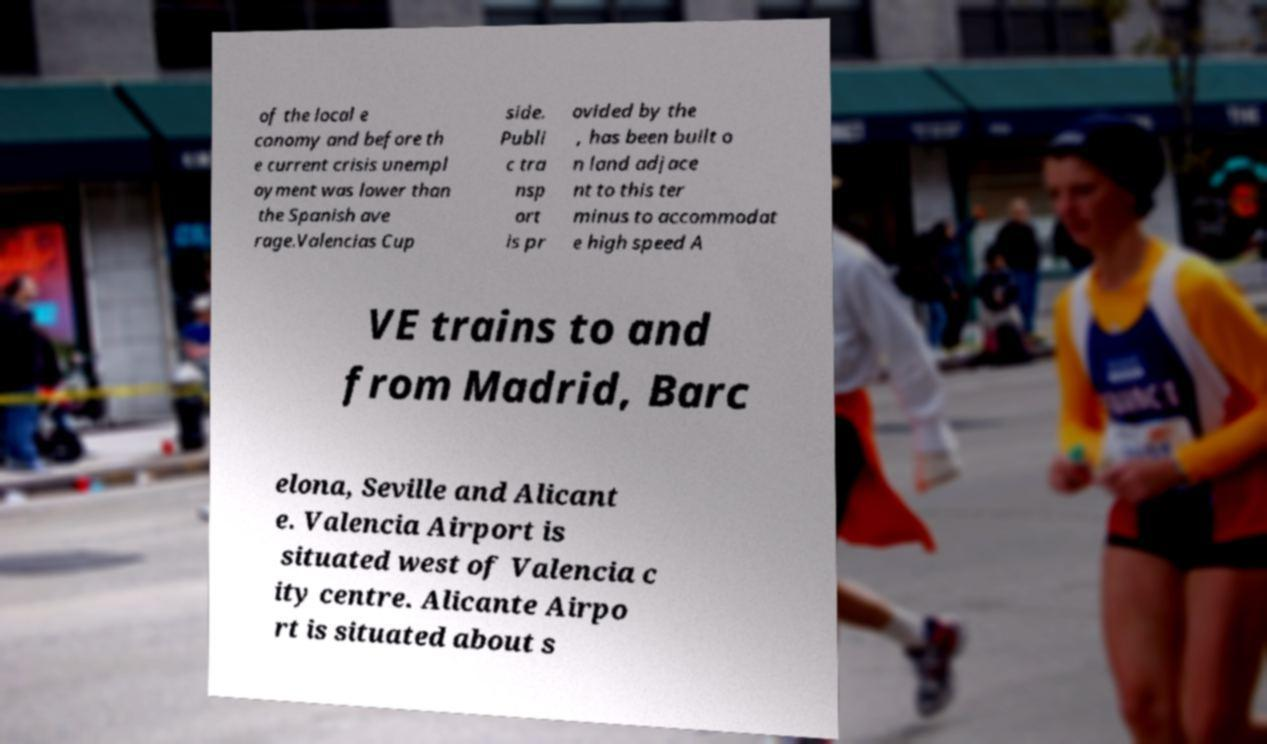For documentation purposes, I need the text within this image transcribed. Could you provide that? of the local e conomy and before th e current crisis unempl oyment was lower than the Spanish ave rage.Valencias Cup side. Publi c tra nsp ort is pr ovided by the , has been built o n land adjace nt to this ter minus to accommodat e high speed A VE trains to and from Madrid, Barc elona, Seville and Alicant e. Valencia Airport is situated west of Valencia c ity centre. Alicante Airpo rt is situated about s 